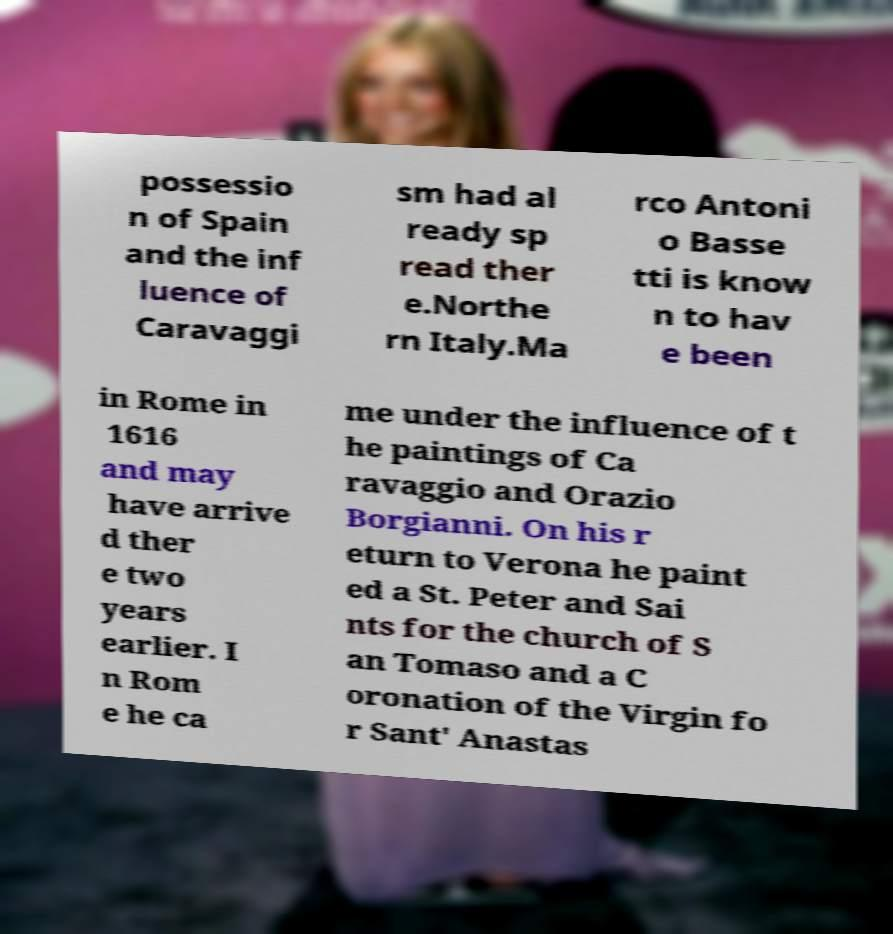There's text embedded in this image that I need extracted. Can you transcribe it verbatim? possessio n of Spain and the inf luence of Caravaggi sm had al ready sp read ther e.Northe rn Italy.Ma rco Antoni o Basse tti is know n to hav e been in Rome in 1616 and may have arrive d ther e two years earlier. I n Rom e he ca me under the influence of t he paintings of Ca ravaggio and Orazio Borgianni. On his r eturn to Verona he paint ed a St. Peter and Sai nts for the church of S an Tomaso and a C oronation of the Virgin fo r Sant' Anastas 